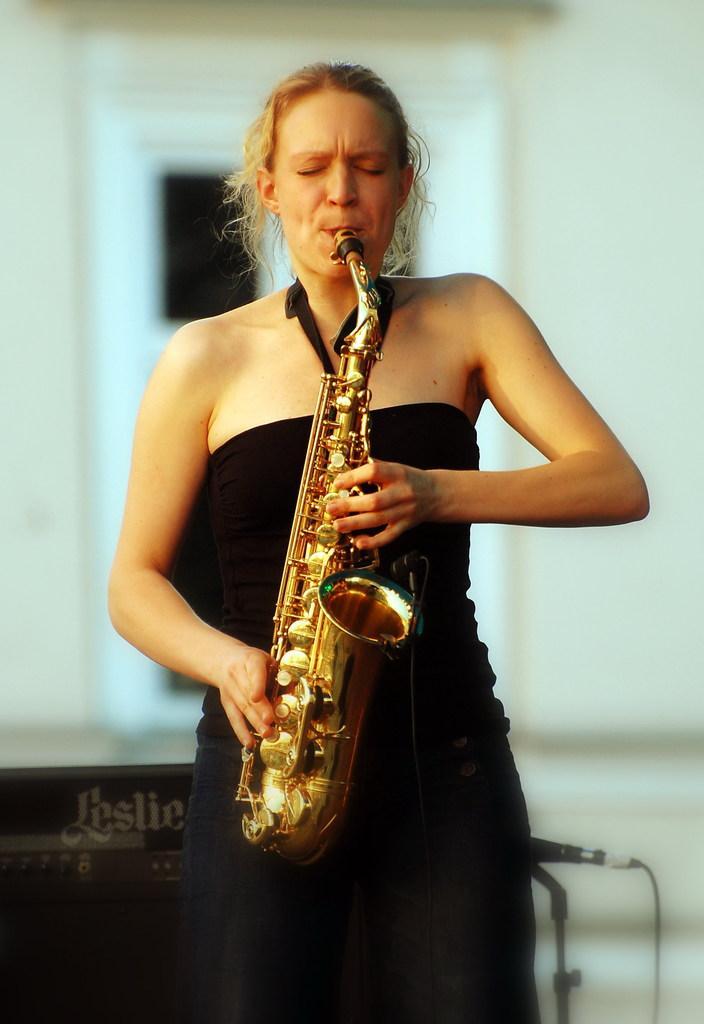In one or two sentences, can you explain what this image depicts? As we can see in the image there is a woman playing musical instrument and in the background there is a white color wall. 